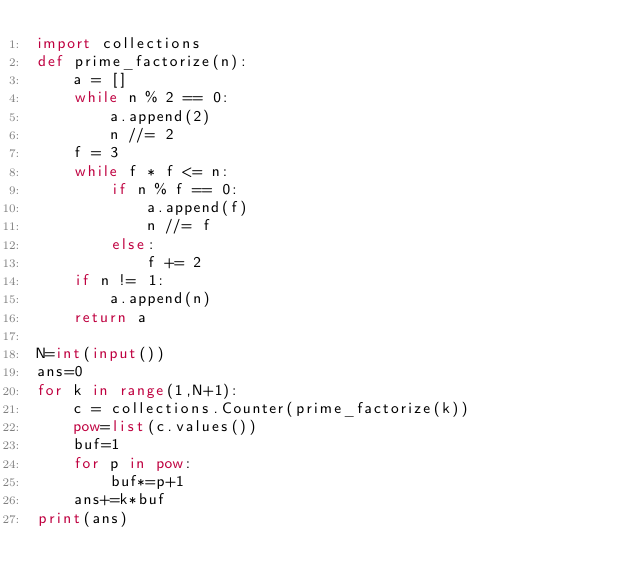<code> <loc_0><loc_0><loc_500><loc_500><_Python_>import collections
def prime_factorize(n):
    a = []
    while n % 2 == 0:
        a.append(2)
        n //= 2
    f = 3
    while f * f <= n:
        if n % f == 0:
            a.append(f)
            n //= f
        else:
            f += 2
    if n != 1:
        a.append(n)
    return a

N=int(input())
ans=0
for k in range(1,N+1):
    c = collections.Counter(prime_factorize(k))
    pow=list(c.values())
    buf=1
    for p in pow:
        buf*=p+1
    ans+=k*buf
print(ans)</code> 